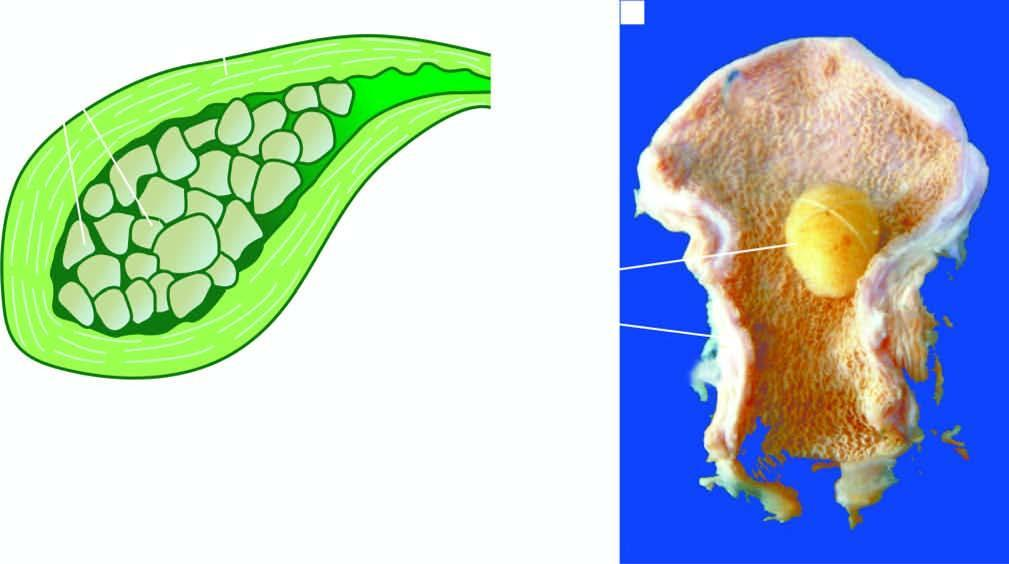does the lumen contain a single, large, oval, and hard yellow-white gallstone?
Answer the question using a single word or phrase. Yes 